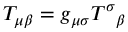<formula> <loc_0><loc_0><loc_500><loc_500>T _ { \mu \beta } = g _ { \mu \sigma } T ^ { \sigma _ { \beta }</formula> 